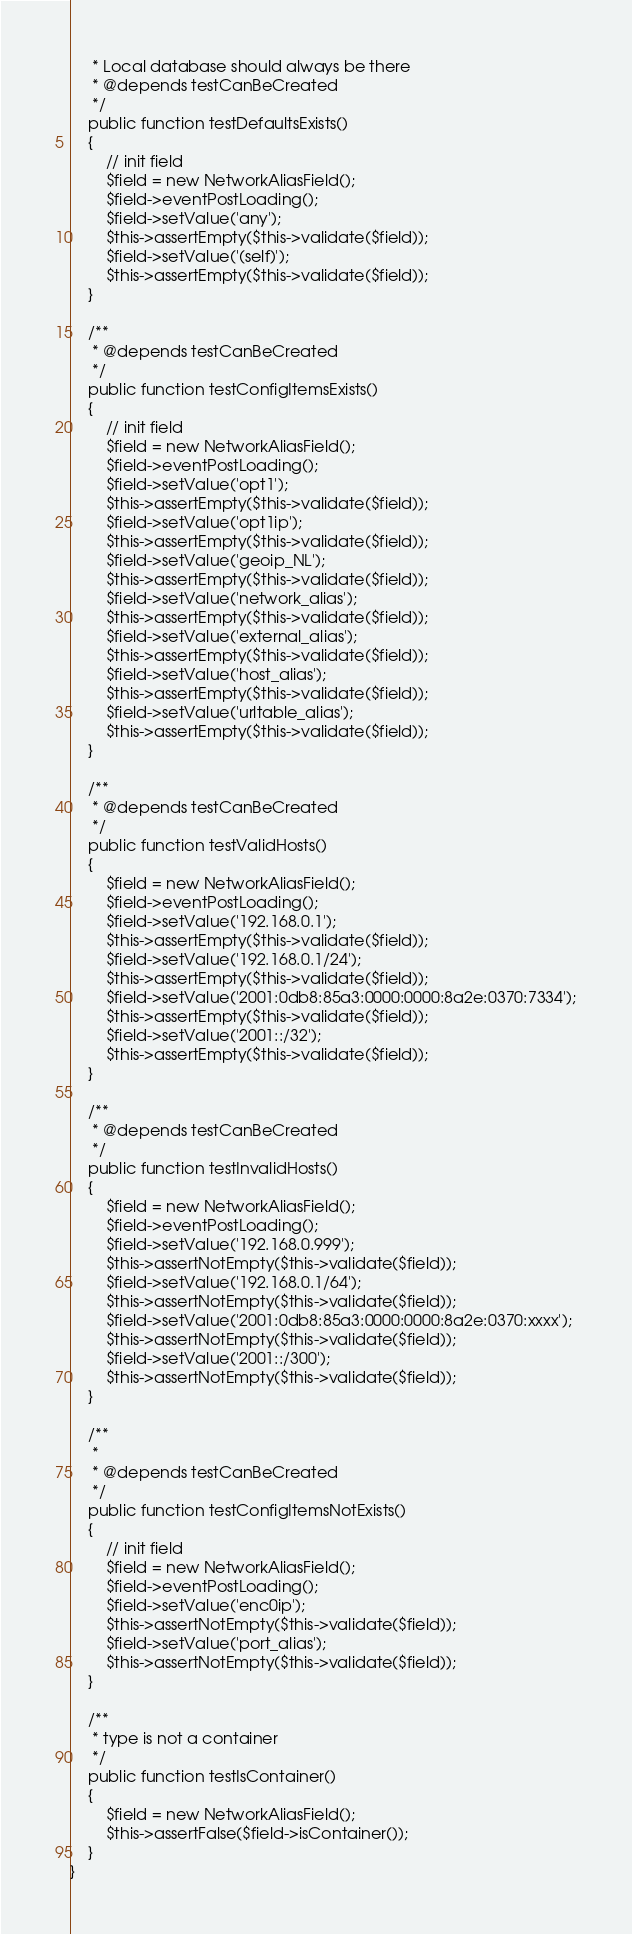Convert code to text. <code><loc_0><loc_0><loc_500><loc_500><_PHP_>     * Local database should always be there
     * @depends testCanBeCreated
     */
    public function testDefaultsExists()
    {
        // init field
        $field = new NetworkAliasField();
        $field->eventPostLoading();
        $field->setValue('any');
        $this->assertEmpty($this->validate($field));
        $field->setValue('(self)');
        $this->assertEmpty($this->validate($field));
    }

    /**
     * @depends testCanBeCreated
     */
    public function testConfigItemsExists()
    {
        // init field
        $field = new NetworkAliasField();
        $field->eventPostLoading();
        $field->setValue('opt1');
        $this->assertEmpty($this->validate($field));
        $field->setValue('opt1ip');
        $this->assertEmpty($this->validate($field));
        $field->setValue('geoip_NL');
        $this->assertEmpty($this->validate($field));
        $field->setValue('network_alias');
        $this->assertEmpty($this->validate($field));
        $field->setValue('external_alias');
        $this->assertEmpty($this->validate($field));
        $field->setValue('host_alias');
        $this->assertEmpty($this->validate($field));
        $field->setValue('urltable_alias');
        $this->assertEmpty($this->validate($field));
    }

    /**
     * @depends testCanBeCreated
     */
    public function testValidHosts()
    {
        $field = new NetworkAliasField();
        $field->eventPostLoading();
        $field->setValue('192.168.0.1');
        $this->assertEmpty($this->validate($field));
        $field->setValue('192.168.0.1/24');
        $this->assertEmpty($this->validate($field));
        $field->setValue('2001:0db8:85a3:0000:0000:8a2e:0370:7334');
        $this->assertEmpty($this->validate($field));
        $field->setValue('2001::/32');
        $this->assertEmpty($this->validate($field));
    }

    /**
     * @depends testCanBeCreated
     */
    public function testInvalidHosts()
    {
        $field = new NetworkAliasField();
        $field->eventPostLoading();
        $field->setValue('192.168.0.999');
        $this->assertNotEmpty($this->validate($field));
        $field->setValue('192.168.0.1/64');
        $this->assertNotEmpty($this->validate($field));
        $field->setValue('2001:0db8:85a3:0000:0000:8a2e:0370:xxxx');
        $this->assertNotEmpty($this->validate($field));
        $field->setValue('2001::/300');
        $this->assertNotEmpty($this->validate($field));
    }

    /**
     *
     * @depends testCanBeCreated
     */
    public function testConfigItemsNotExists()
    {
        // init field
        $field = new NetworkAliasField();
        $field->eventPostLoading();
        $field->setValue('enc0ip');
        $this->assertNotEmpty($this->validate($field));
        $field->setValue('port_alias');
        $this->assertNotEmpty($this->validate($field));
    }

    /**
     * type is not a container
     */
    public function testIsContainer()
    {
        $field = new NetworkAliasField();
        $this->assertFalse($field->isContainer());
    }
}
</code> 